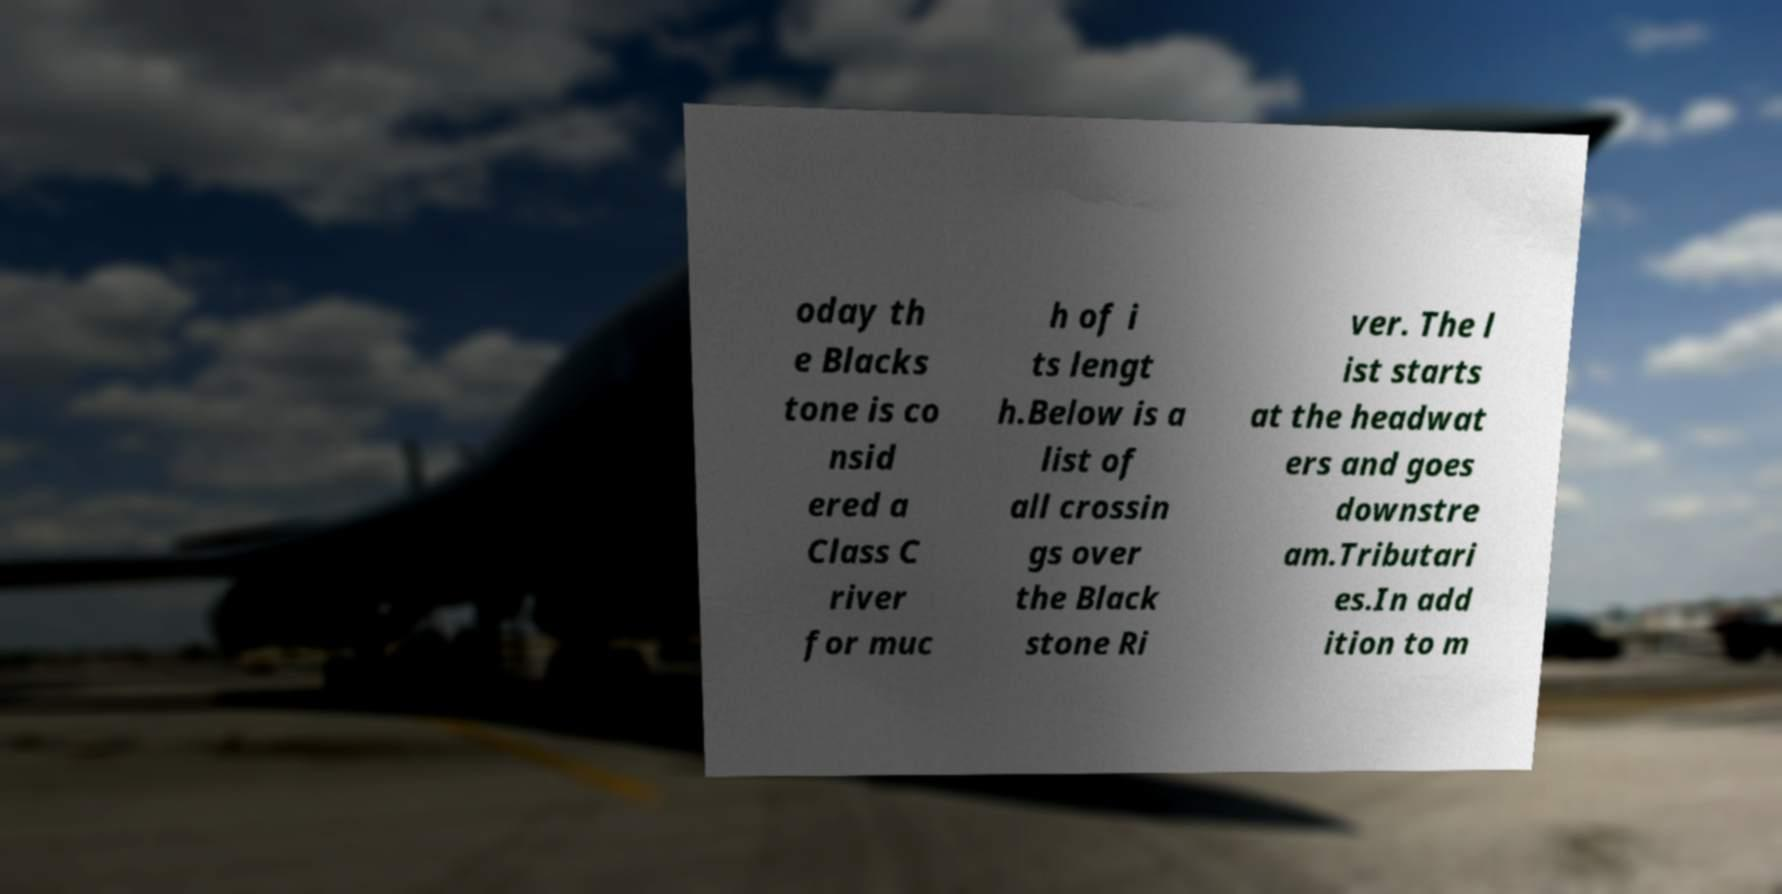What messages or text are displayed in this image? I need them in a readable, typed format. oday th e Blacks tone is co nsid ered a Class C river for muc h of i ts lengt h.Below is a list of all crossin gs over the Black stone Ri ver. The l ist starts at the headwat ers and goes downstre am.Tributari es.In add ition to m 